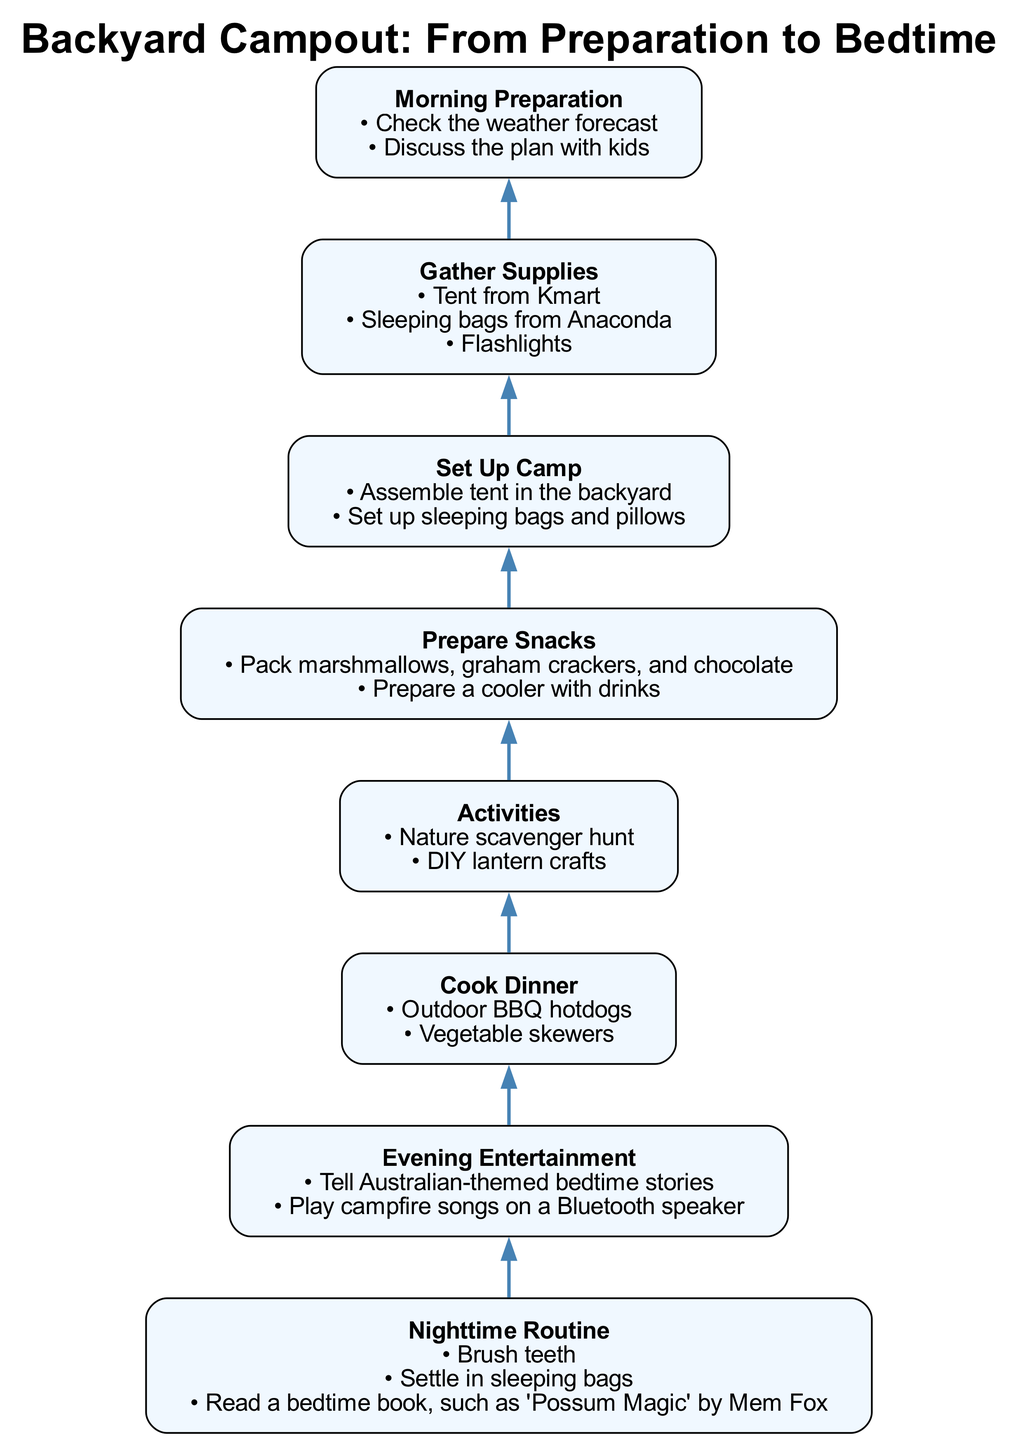What is the first step in the campout preparation? The first step listed in the diagram is "Morning Preparation." This is the bottommost node in the flow, indicating it should be completed first.
Answer: Morning Preparation How many activities are mentioned in the diagram? There are two activities listed under the "Activities" step in the diagram: "Nature scavenger hunt" and "DIY lantern crafts." Therefore, the total number of activities is two.
Answer: 2 Which supplies should be gathered first? According to the diagram, the "Gather Supplies" step follows "Morning Preparation," indicating that supplies should be gathered right after the morning preparations. The supplies listed include a tent from Kmart, sleeping bags from Anaconda, and flashlights.
Answer: Tent, sleeping bags, flashlights What comes before "Cook Dinner"? In the flow of the diagram, the step that directly precedes "Cook Dinner" is "Prepare Snacks." This means that after preparing snacks, the next action is to cook dinner.
Answer: Prepare Snacks Which step includes bedtime stories? The "Evening Entertainment" step includes telling Australian-themed bedtime stories. This is part of the process of keeping children entertained during the campout.
Answer: Evening Entertainment What is the last activity in the campout process? The final node in the flow chart is "Nighttime Routine." This indicates that after all other steps, the last activity involves settling in for bed.
Answer: Nighttime Routine Which step includes "Outdoor BBQ hotdogs"? The step labeled "Cook Dinner" specifically includes "Outdoor BBQ hotdogs" as part of what to prepare for dinner during the campout. This step appears before the entertainment and bedtime routines.
Answer: Cook Dinner Is there any step that directly leads to "Set Up Camp"? Yes, the "Gather Supplies" step directly leads to the "Set Up Camp" step in the flow. This means that once the supplies are gathered, the next action is to set up the camp.
Answer: Yes, Gather Supplies 